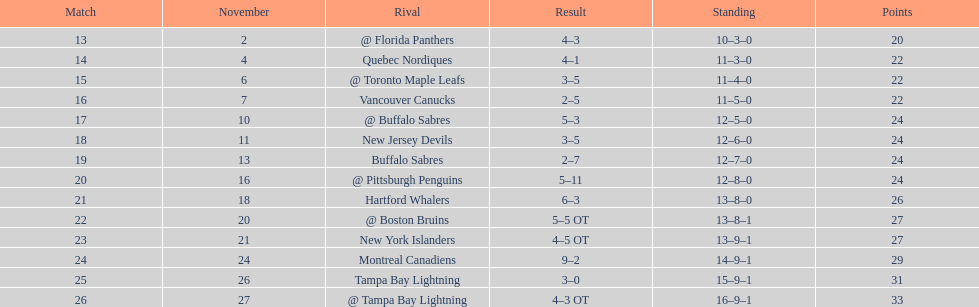Were the new jersey devils in last place according to the chart? No. 